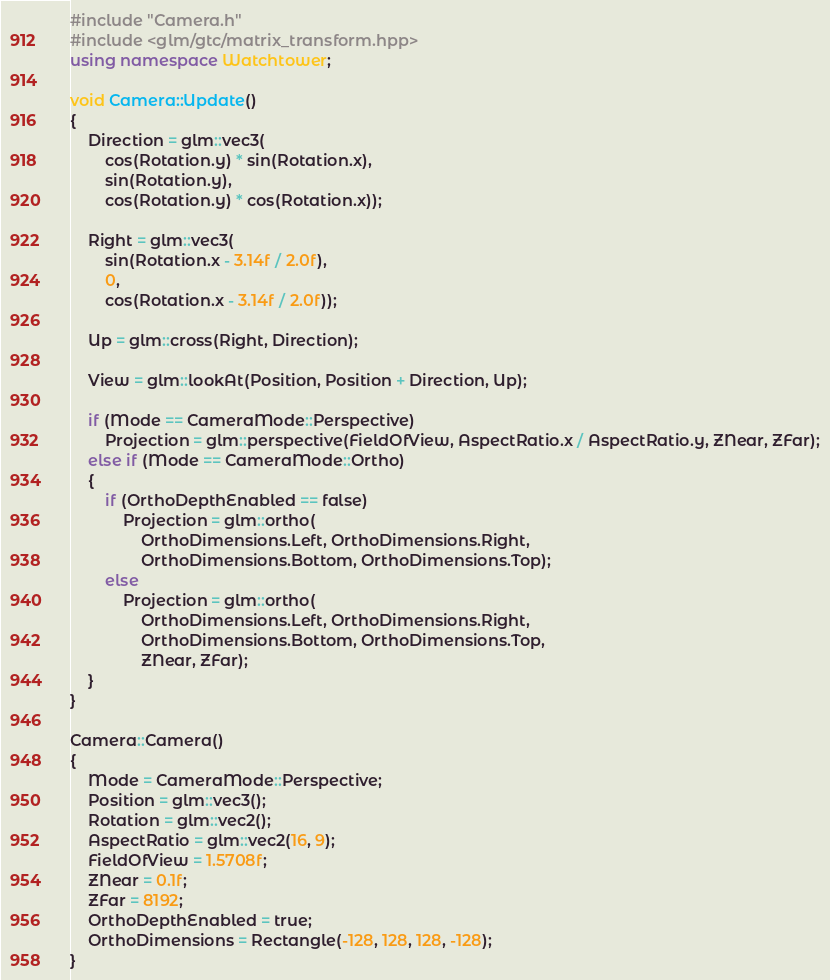Convert code to text. <code><loc_0><loc_0><loc_500><loc_500><_C++_>#include "Camera.h"
#include <glm/gtc/matrix_transform.hpp>
using namespace Watchtower;

void Camera::Update()
{
	Direction = glm::vec3(
		cos(Rotation.y) * sin(Rotation.x),
		sin(Rotation.y),
		cos(Rotation.y) * cos(Rotation.x));

	Right = glm::vec3(
		sin(Rotation.x - 3.14f / 2.0f),
		0,
		cos(Rotation.x - 3.14f / 2.0f));

	Up = glm::cross(Right, Direction);

	View = glm::lookAt(Position, Position + Direction, Up);

	if (Mode == CameraMode::Perspective)
		Projection = glm::perspective(FieldOfView, AspectRatio.x / AspectRatio.y, ZNear, ZFar);
	else if (Mode == CameraMode::Ortho)
	{
		if (OrthoDepthEnabled == false)
			Projection = glm::ortho(
				OrthoDimensions.Left, OrthoDimensions.Right,
				OrthoDimensions.Bottom, OrthoDimensions.Top);
		else
			Projection = glm::ortho(
				OrthoDimensions.Left, OrthoDimensions.Right,
				OrthoDimensions.Bottom, OrthoDimensions.Top,
				ZNear, ZFar);
	}
}

Camera::Camera()
{
	Mode = CameraMode::Perspective;
	Position = glm::vec3();
	Rotation = glm::vec2();
	AspectRatio = glm::vec2(16, 9);
	FieldOfView = 1.5708f;
	ZNear = 0.1f;
	ZFar = 8192;
	OrthoDepthEnabled = true;
	OrthoDimensions = Rectangle(-128, 128, 128, -128);
}
</code> 